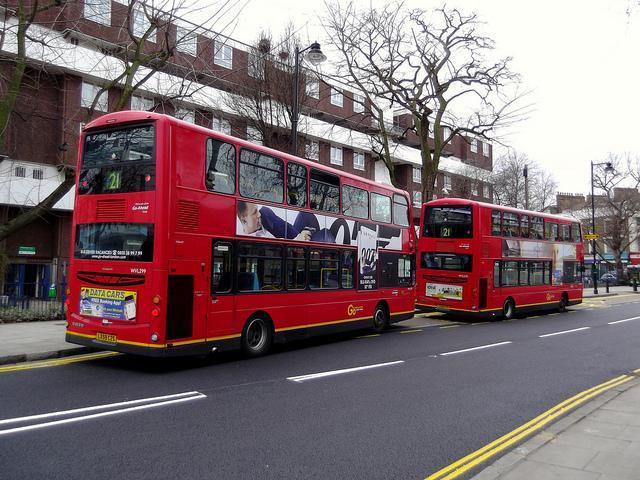How many buses are there?
Give a very brief answer. 2. How many buses are in the photo?
Give a very brief answer. 2. How many women are there?
Give a very brief answer. 0. 